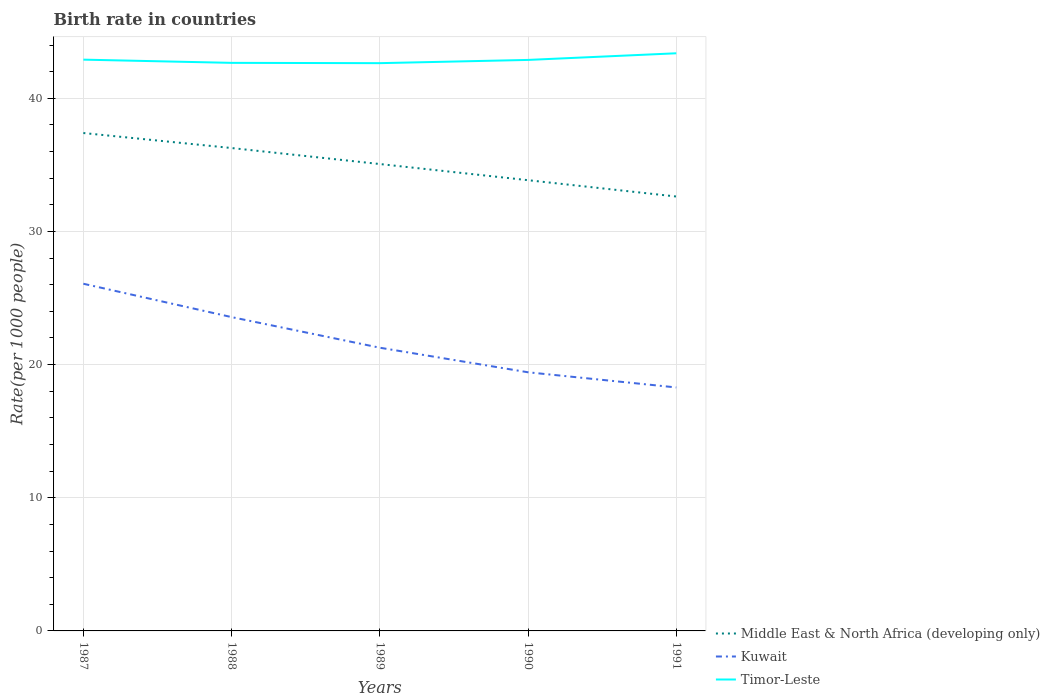How many different coloured lines are there?
Provide a succinct answer. 3. Does the line corresponding to Kuwait intersect with the line corresponding to Timor-Leste?
Your response must be concise. No. Is the number of lines equal to the number of legend labels?
Your answer should be compact. Yes. Across all years, what is the maximum birth rate in Timor-Leste?
Your answer should be very brief. 42.64. What is the total birth rate in Kuwait in the graph?
Your response must be concise. 2.3. What is the difference between the highest and the second highest birth rate in Kuwait?
Give a very brief answer. 7.79. What is the difference between the highest and the lowest birth rate in Middle East & North Africa (developing only)?
Keep it short and to the point. 3. How many lines are there?
Provide a short and direct response. 3. How many years are there in the graph?
Make the answer very short. 5. Are the values on the major ticks of Y-axis written in scientific E-notation?
Give a very brief answer. No. Does the graph contain any zero values?
Offer a very short reply. No. Does the graph contain grids?
Keep it short and to the point. Yes. How many legend labels are there?
Your answer should be compact. 3. How are the legend labels stacked?
Offer a terse response. Vertical. What is the title of the graph?
Ensure brevity in your answer.  Birth rate in countries. Does "Eritrea" appear as one of the legend labels in the graph?
Your response must be concise. No. What is the label or title of the Y-axis?
Provide a succinct answer. Rate(per 1000 people). What is the Rate(per 1000 people) of Middle East & North Africa (developing only) in 1987?
Ensure brevity in your answer.  37.39. What is the Rate(per 1000 people) of Kuwait in 1987?
Provide a succinct answer. 26.07. What is the Rate(per 1000 people) in Timor-Leste in 1987?
Make the answer very short. 42.9. What is the Rate(per 1000 people) of Middle East & North Africa (developing only) in 1988?
Your answer should be very brief. 36.26. What is the Rate(per 1000 people) of Kuwait in 1988?
Offer a very short reply. 23.57. What is the Rate(per 1000 people) in Timor-Leste in 1988?
Provide a succinct answer. 42.66. What is the Rate(per 1000 people) in Middle East & North Africa (developing only) in 1989?
Keep it short and to the point. 35.06. What is the Rate(per 1000 people) in Kuwait in 1989?
Keep it short and to the point. 21.27. What is the Rate(per 1000 people) in Timor-Leste in 1989?
Give a very brief answer. 42.64. What is the Rate(per 1000 people) of Middle East & North Africa (developing only) in 1990?
Provide a short and direct response. 33.85. What is the Rate(per 1000 people) in Kuwait in 1990?
Offer a very short reply. 19.42. What is the Rate(per 1000 people) of Timor-Leste in 1990?
Keep it short and to the point. 42.88. What is the Rate(per 1000 people) in Middle East & North Africa (developing only) in 1991?
Offer a terse response. 32.62. What is the Rate(per 1000 people) of Kuwait in 1991?
Provide a short and direct response. 18.29. What is the Rate(per 1000 people) in Timor-Leste in 1991?
Your answer should be very brief. 43.38. Across all years, what is the maximum Rate(per 1000 people) of Middle East & North Africa (developing only)?
Your response must be concise. 37.39. Across all years, what is the maximum Rate(per 1000 people) in Kuwait?
Your response must be concise. 26.07. Across all years, what is the maximum Rate(per 1000 people) of Timor-Leste?
Your response must be concise. 43.38. Across all years, what is the minimum Rate(per 1000 people) of Middle East & North Africa (developing only)?
Make the answer very short. 32.62. Across all years, what is the minimum Rate(per 1000 people) of Kuwait?
Keep it short and to the point. 18.29. Across all years, what is the minimum Rate(per 1000 people) in Timor-Leste?
Your answer should be very brief. 42.64. What is the total Rate(per 1000 people) of Middle East & North Africa (developing only) in the graph?
Ensure brevity in your answer.  175.2. What is the total Rate(per 1000 people) of Kuwait in the graph?
Give a very brief answer. 108.62. What is the total Rate(per 1000 people) of Timor-Leste in the graph?
Offer a terse response. 214.47. What is the difference between the Rate(per 1000 people) of Middle East & North Africa (developing only) in 1987 and that in 1988?
Provide a short and direct response. 1.13. What is the difference between the Rate(per 1000 people) in Kuwait in 1987 and that in 1988?
Offer a very short reply. 2.5. What is the difference between the Rate(per 1000 people) of Timor-Leste in 1987 and that in 1988?
Ensure brevity in your answer.  0.24. What is the difference between the Rate(per 1000 people) of Middle East & North Africa (developing only) in 1987 and that in 1989?
Give a very brief answer. 2.33. What is the difference between the Rate(per 1000 people) in Kuwait in 1987 and that in 1989?
Provide a short and direct response. 4.8. What is the difference between the Rate(per 1000 people) in Timor-Leste in 1987 and that in 1989?
Provide a succinct answer. 0.26. What is the difference between the Rate(per 1000 people) in Middle East & North Africa (developing only) in 1987 and that in 1990?
Offer a terse response. 3.54. What is the difference between the Rate(per 1000 people) in Kuwait in 1987 and that in 1990?
Make the answer very short. 6.65. What is the difference between the Rate(per 1000 people) in Timor-Leste in 1987 and that in 1990?
Provide a succinct answer. 0.02. What is the difference between the Rate(per 1000 people) in Middle East & North Africa (developing only) in 1987 and that in 1991?
Give a very brief answer. 4.77. What is the difference between the Rate(per 1000 people) in Kuwait in 1987 and that in 1991?
Your answer should be compact. 7.79. What is the difference between the Rate(per 1000 people) of Timor-Leste in 1987 and that in 1991?
Make the answer very short. -0.48. What is the difference between the Rate(per 1000 people) in Middle East & North Africa (developing only) in 1988 and that in 1989?
Ensure brevity in your answer.  1.2. What is the difference between the Rate(per 1000 people) of Kuwait in 1988 and that in 1989?
Offer a terse response. 2.3. What is the difference between the Rate(per 1000 people) of Timor-Leste in 1988 and that in 1989?
Ensure brevity in your answer.  0.02. What is the difference between the Rate(per 1000 people) of Middle East & North Africa (developing only) in 1988 and that in 1990?
Provide a succinct answer. 2.41. What is the difference between the Rate(per 1000 people) in Kuwait in 1988 and that in 1990?
Make the answer very short. 4.14. What is the difference between the Rate(per 1000 people) of Timor-Leste in 1988 and that in 1990?
Your answer should be compact. -0.22. What is the difference between the Rate(per 1000 people) of Middle East & North Africa (developing only) in 1988 and that in 1991?
Make the answer very short. 3.64. What is the difference between the Rate(per 1000 people) of Kuwait in 1988 and that in 1991?
Offer a very short reply. 5.28. What is the difference between the Rate(per 1000 people) of Timor-Leste in 1988 and that in 1991?
Give a very brief answer. -0.72. What is the difference between the Rate(per 1000 people) in Middle East & North Africa (developing only) in 1989 and that in 1990?
Provide a short and direct response. 1.21. What is the difference between the Rate(per 1000 people) of Kuwait in 1989 and that in 1990?
Give a very brief answer. 1.84. What is the difference between the Rate(per 1000 people) in Timor-Leste in 1989 and that in 1990?
Offer a very short reply. -0.24. What is the difference between the Rate(per 1000 people) in Middle East & North Africa (developing only) in 1989 and that in 1991?
Provide a succinct answer. 2.44. What is the difference between the Rate(per 1000 people) of Kuwait in 1989 and that in 1991?
Keep it short and to the point. 2.98. What is the difference between the Rate(per 1000 people) of Timor-Leste in 1989 and that in 1991?
Give a very brief answer. -0.74. What is the difference between the Rate(per 1000 people) of Middle East & North Africa (developing only) in 1990 and that in 1991?
Your answer should be compact. 1.23. What is the difference between the Rate(per 1000 people) in Kuwait in 1990 and that in 1991?
Give a very brief answer. 1.14. What is the difference between the Rate(per 1000 people) in Timor-Leste in 1990 and that in 1991?
Your answer should be compact. -0.5. What is the difference between the Rate(per 1000 people) in Middle East & North Africa (developing only) in 1987 and the Rate(per 1000 people) in Kuwait in 1988?
Offer a terse response. 13.82. What is the difference between the Rate(per 1000 people) of Middle East & North Africa (developing only) in 1987 and the Rate(per 1000 people) of Timor-Leste in 1988?
Provide a short and direct response. -5.27. What is the difference between the Rate(per 1000 people) in Kuwait in 1987 and the Rate(per 1000 people) in Timor-Leste in 1988?
Offer a terse response. -16.59. What is the difference between the Rate(per 1000 people) of Middle East & North Africa (developing only) in 1987 and the Rate(per 1000 people) of Kuwait in 1989?
Your answer should be very brief. 16.12. What is the difference between the Rate(per 1000 people) of Middle East & North Africa (developing only) in 1987 and the Rate(per 1000 people) of Timor-Leste in 1989?
Provide a short and direct response. -5.25. What is the difference between the Rate(per 1000 people) in Kuwait in 1987 and the Rate(per 1000 people) in Timor-Leste in 1989?
Your answer should be very brief. -16.57. What is the difference between the Rate(per 1000 people) of Middle East & North Africa (developing only) in 1987 and the Rate(per 1000 people) of Kuwait in 1990?
Ensure brevity in your answer.  17.97. What is the difference between the Rate(per 1000 people) of Middle East & North Africa (developing only) in 1987 and the Rate(per 1000 people) of Timor-Leste in 1990?
Ensure brevity in your answer.  -5.49. What is the difference between the Rate(per 1000 people) of Kuwait in 1987 and the Rate(per 1000 people) of Timor-Leste in 1990?
Your response must be concise. -16.81. What is the difference between the Rate(per 1000 people) of Middle East & North Africa (developing only) in 1987 and the Rate(per 1000 people) of Kuwait in 1991?
Offer a very short reply. 19.11. What is the difference between the Rate(per 1000 people) of Middle East & North Africa (developing only) in 1987 and the Rate(per 1000 people) of Timor-Leste in 1991?
Your answer should be compact. -5.99. What is the difference between the Rate(per 1000 people) in Kuwait in 1987 and the Rate(per 1000 people) in Timor-Leste in 1991?
Offer a very short reply. -17.31. What is the difference between the Rate(per 1000 people) in Middle East & North Africa (developing only) in 1988 and the Rate(per 1000 people) in Kuwait in 1989?
Your response must be concise. 15. What is the difference between the Rate(per 1000 people) of Middle East & North Africa (developing only) in 1988 and the Rate(per 1000 people) of Timor-Leste in 1989?
Your response must be concise. -6.38. What is the difference between the Rate(per 1000 people) in Kuwait in 1988 and the Rate(per 1000 people) in Timor-Leste in 1989?
Make the answer very short. -19.07. What is the difference between the Rate(per 1000 people) of Middle East & North Africa (developing only) in 1988 and the Rate(per 1000 people) of Kuwait in 1990?
Make the answer very short. 16.84. What is the difference between the Rate(per 1000 people) in Middle East & North Africa (developing only) in 1988 and the Rate(per 1000 people) in Timor-Leste in 1990?
Offer a very short reply. -6.62. What is the difference between the Rate(per 1000 people) of Kuwait in 1988 and the Rate(per 1000 people) of Timor-Leste in 1990?
Your response must be concise. -19.31. What is the difference between the Rate(per 1000 people) in Middle East & North Africa (developing only) in 1988 and the Rate(per 1000 people) in Kuwait in 1991?
Keep it short and to the point. 17.98. What is the difference between the Rate(per 1000 people) in Middle East & North Africa (developing only) in 1988 and the Rate(per 1000 people) in Timor-Leste in 1991?
Give a very brief answer. -7.12. What is the difference between the Rate(per 1000 people) of Kuwait in 1988 and the Rate(per 1000 people) of Timor-Leste in 1991?
Your response must be concise. -19.81. What is the difference between the Rate(per 1000 people) of Middle East & North Africa (developing only) in 1989 and the Rate(per 1000 people) of Kuwait in 1990?
Your response must be concise. 15.64. What is the difference between the Rate(per 1000 people) of Middle East & North Africa (developing only) in 1989 and the Rate(per 1000 people) of Timor-Leste in 1990?
Give a very brief answer. -7.82. What is the difference between the Rate(per 1000 people) of Kuwait in 1989 and the Rate(per 1000 people) of Timor-Leste in 1990?
Provide a short and direct response. -21.61. What is the difference between the Rate(per 1000 people) of Middle East & North Africa (developing only) in 1989 and the Rate(per 1000 people) of Kuwait in 1991?
Offer a terse response. 16.78. What is the difference between the Rate(per 1000 people) in Middle East & North Africa (developing only) in 1989 and the Rate(per 1000 people) in Timor-Leste in 1991?
Ensure brevity in your answer.  -8.32. What is the difference between the Rate(per 1000 people) in Kuwait in 1989 and the Rate(per 1000 people) in Timor-Leste in 1991?
Your answer should be compact. -22.11. What is the difference between the Rate(per 1000 people) of Middle East & North Africa (developing only) in 1990 and the Rate(per 1000 people) of Kuwait in 1991?
Provide a succinct answer. 15.57. What is the difference between the Rate(per 1000 people) of Middle East & North Africa (developing only) in 1990 and the Rate(per 1000 people) of Timor-Leste in 1991?
Your response must be concise. -9.53. What is the difference between the Rate(per 1000 people) of Kuwait in 1990 and the Rate(per 1000 people) of Timor-Leste in 1991?
Offer a terse response. -23.96. What is the average Rate(per 1000 people) of Middle East & North Africa (developing only) per year?
Make the answer very short. 35.04. What is the average Rate(per 1000 people) in Kuwait per year?
Your answer should be compact. 21.72. What is the average Rate(per 1000 people) of Timor-Leste per year?
Your answer should be compact. 42.89. In the year 1987, what is the difference between the Rate(per 1000 people) in Middle East & North Africa (developing only) and Rate(per 1000 people) in Kuwait?
Provide a short and direct response. 11.32. In the year 1987, what is the difference between the Rate(per 1000 people) in Middle East & North Africa (developing only) and Rate(per 1000 people) in Timor-Leste?
Keep it short and to the point. -5.51. In the year 1987, what is the difference between the Rate(per 1000 people) in Kuwait and Rate(per 1000 people) in Timor-Leste?
Provide a short and direct response. -16.83. In the year 1988, what is the difference between the Rate(per 1000 people) in Middle East & North Africa (developing only) and Rate(per 1000 people) in Kuwait?
Provide a short and direct response. 12.7. In the year 1988, what is the difference between the Rate(per 1000 people) in Middle East & North Africa (developing only) and Rate(per 1000 people) in Timor-Leste?
Offer a very short reply. -6.4. In the year 1988, what is the difference between the Rate(per 1000 people) of Kuwait and Rate(per 1000 people) of Timor-Leste?
Your answer should be compact. -19.09. In the year 1989, what is the difference between the Rate(per 1000 people) in Middle East & North Africa (developing only) and Rate(per 1000 people) in Kuwait?
Ensure brevity in your answer.  13.79. In the year 1989, what is the difference between the Rate(per 1000 people) in Middle East & North Africa (developing only) and Rate(per 1000 people) in Timor-Leste?
Your answer should be very brief. -7.58. In the year 1989, what is the difference between the Rate(per 1000 people) in Kuwait and Rate(per 1000 people) in Timor-Leste?
Keep it short and to the point. -21.37. In the year 1990, what is the difference between the Rate(per 1000 people) of Middle East & North Africa (developing only) and Rate(per 1000 people) of Kuwait?
Keep it short and to the point. 14.43. In the year 1990, what is the difference between the Rate(per 1000 people) in Middle East & North Africa (developing only) and Rate(per 1000 people) in Timor-Leste?
Your answer should be compact. -9.03. In the year 1990, what is the difference between the Rate(per 1000 people) of Kuwait and Rate(per 1000 people) of Timor-Leste?
Offer a very short reply. -23.46. In the year 1991, what is the difference between the Rate(per 1000 people) of Middle East & North Africa (developing only) and Rate(per 1000 people) of Kuwait?
Offer a very short reply. 14.34. In the year 1991, what is the difference between the Rate(per 1000 people) of Middle East & North Africa (developing only) and Rate(per 1000 people) of Timor-Leste?
Make the answer very short. -10.76. In the year 1991, what is the difference between the Rate(per 1000 people) of Kuwait and Rate(per 1000 people) of Timor-Leste?
Provide a short and direct response. -25.1. What is the ratio of the Rate(per 1000 people) of Middle East & North Africa (developing only) in 1987 to that in 1988?
Make the answer very short. 1.03. What is the ratio of the Rate(per 1000 people) in Kuwait in 1987 to that in 1988?
Offer a terse response. 1.11. What is the ratio of the Rate(per 1000 people) in Timor-Leste in 1987 to that in 1988?
Your answer should be very brief. 1.01. What is the ratio of the Rate(per 1000 people) in Middle East & North Africa (developing only) in 1987 to that in 1989?
Give a very brief answer. 1.07. What is the ratio of the Rate(per 1000 people) of Kuwait in 1987 to that in 1989?
Make the answer very short. 1.23. What is the ratio of the Rate(per 1000 people) of Middle East & North Africa (developing only) in 1987 to that in 1990?
Make the answer very short. 1.1. What is the ratio of the Rate(per 1000 people) of Kuwait in 1987 to that in 1990?
Your answer should be very brief. 1.34. What is the ratio of the Rate(per 1000 people) in Timor-Leste in 1987 to that in 1990?
Your answer should be compact. 1. What is the ratio of the Rate(per 1000 people) of Middle East & North Africa (developing only) in 1987 to that in 1991?
Offer a terse response. 1.15. What is the ratio of the Rate(per 1000 people) in Kuwait in 1987 to that in 1991?
Give a very brief answer. 1.43. What is the ratio of the Rate(per 1000 people) of Timor-Leste in 1987 to that in 1991?
Provide a succinct answer. 0.99. What is the ratio of the Rate(per 1000 people) of Middle East & North Africa (developing only) in 1988 to that in 1989?
Offer a very short reply. 1.03. What is the ratio of the Rate(per 1000 people) of Kuwait in 1988 to that in 1989?
Your answer should be very brief. 1.11. What is the ratio of the Rate(per 1000 people) of Timor-Leste in 1988 to that in 1989?
Provide a succinct answer. 1. What is the ratio of the Rate(per 1000 people) in Middle East & North Africa (developing only) in 1988 to that in 1990?
Your answer should be very brief. 1.07. What is the ratio of the Rate(per 1000 people) in Kuwait in 1988 to that in 1990?
Keep it short and to the point. 1.21. What is the ratio of the Rate(per 1000 people) of Middle East & North Africa (developing only) in 1988 to that in 1991?
Your answer should be very brief. 1.11. What is the ratio of the Rate(per 1000 people) of Kuwait in 1988 to that in 1991?
Offer a very short reply. 1.29. What is the ratio of the Rate(per 1000 people) of Timor-Leste in 1988 to that in 1991?
Ensure brevity in your answer.  0.98. What is the ratio of the Rate(per 1000 people) in Middle East & North Africa (developing only) in 1989 to that in 1990?
Ensure brevity in your answer.  1.04. What is the ratio of the Rate(per 1000 people) of Kuwait in 1989 to that in 1990?
Offer a terse response. 1.09. What is the ratio of the Rate(per 1000 people) in Timor-Leste in 1989 to that in 1990?
Provide a succinct answer. 0.99. What is the ratio of the Rate(per 1000 people) in Middle East & North Africa (developing only) in 1989 to that in 1991?
Your answer should be very brief. 1.07. What is the ratio of the Rate(per 1000 people) of Kuwait in 1989 to that in 1991?
Your answer should be compact. 1.16. What is the ratio of the Rate(per 1000 people) in Timor-Leste in 1989 to that in 1991?
Your response must be concise. 0.98. What is the ratio of the Rate(per 1000 people) of Middle East & North Africa (developing only) in 1990 to that in 1991?
Give a very brief answer. 1.04. What is the ratio of the Rate(per 1000 people) in Kuwait in 1990 to that in 1991?
Offer a very short reply. 1.06. What is the ratio of the Rate(per 1000 people) of Timor-Leste in 1990 to that in 1991?
Ensure brevity in your answer.  0.99. What is the difference between the highest and the second highest Rate(per 1000 people) of Middle East & North Africa (developing only)?
Provide a succinct answer. 1.13. What is the difference between the highest and the second highest Rate(per 1000 people) of Kuwait?
Your answer should be compact. 2.5. What is the difference between the highest and the second highest Rate(per 1000 people) of Timor-Leste?
Ensure brevity in your answer.  0.48. What is the difference between the highest and the lowest Rate(per 1000 people) in Middle East & North Africa (developing only)?
Provide a succinct answer. 4.77. What is the difference between the highest and the lowest Rate(per 1000 people) of Kuwait?
Provide a short and direct response. 7.79. What is the difference between the highest and the lowest Rate(per 1000 people) of Timor-Leste?
Provide a short and direct response. 0.74. 